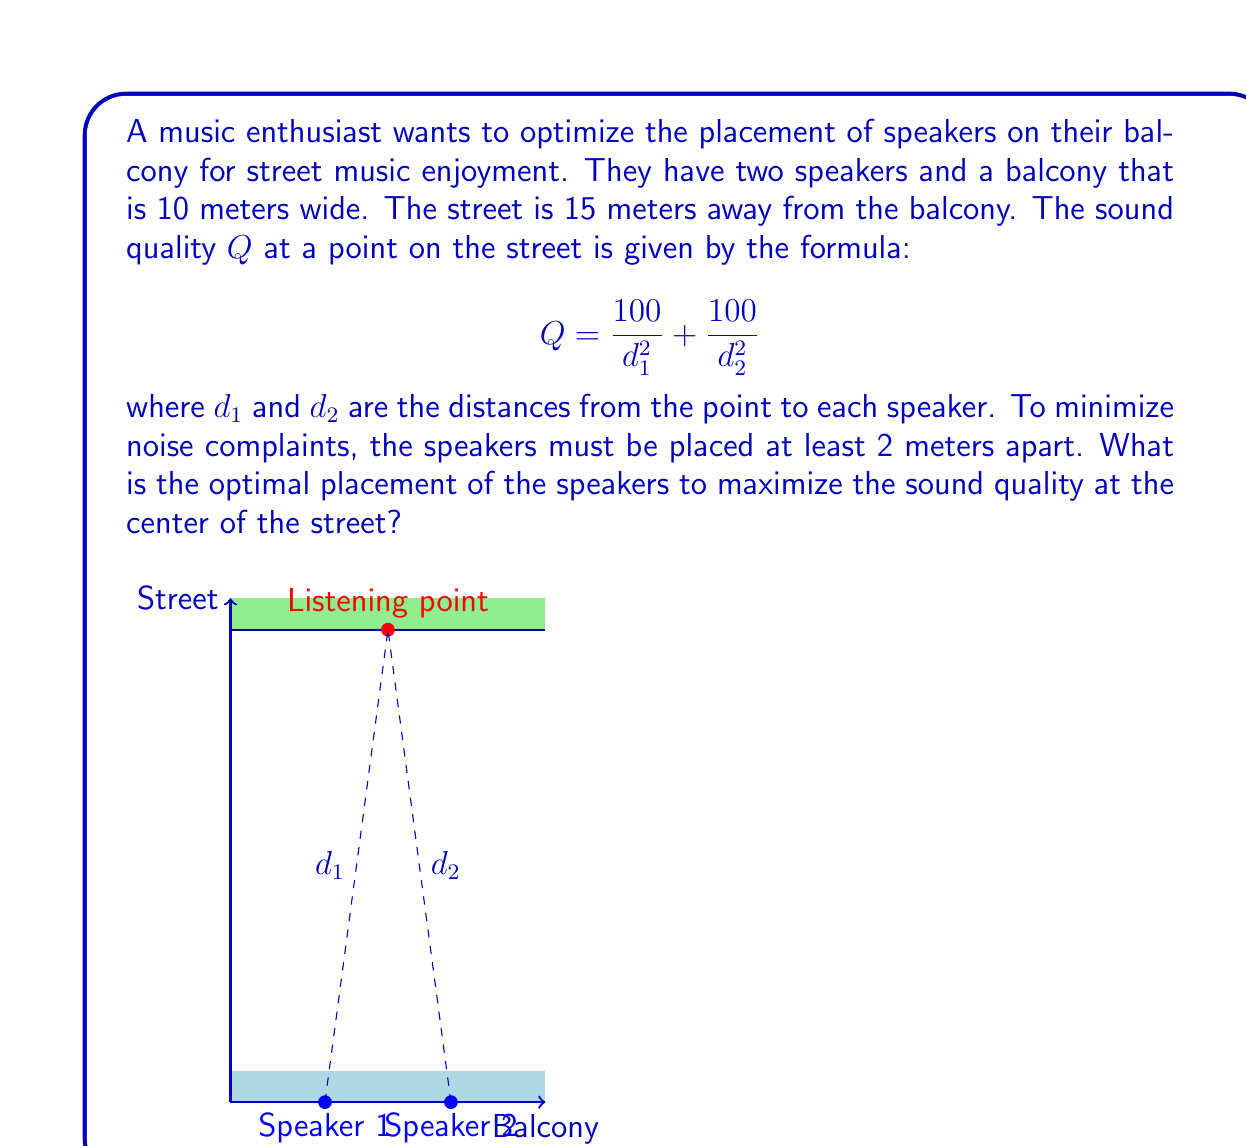Could you help me with this problem? Let's approach this step-by-step:

1) Let the positions of the speakers be $x$ and $10-x$ meters from the left edge of the balcony. Due to symmetry, the optimal placement will be equidistant from the center.

2) The distance $d_1$ from the first speaker to the listening point is:
   $$d_1 = \sqrt{(5-x)^2 + 15^2}$$

3) Similarly, for the second speaker:
   $$d_2 = \sqrt{(5-(10-x))^2 + 15^2} = \sqrt{(x-5)^2 + 15^2}$$

4) The sound quality function becomes:
   $$Q = \frac{100}{(5-x)^2 + 15^2} + \frac{100}{(x-5)^2 + 15^2}$$

5) To maximize Q, we need to minimize the denominator. Let's call the denominator D:
   $$D = (5-x)^2 + 15^2 + (x-5)^2 + 15^2 = 2((x-5)^2 + 15^2)$$

6) To find the minimum, we differentiate D with respect to x and set it to zero:
   $$\frac{dD}{dx} = 4(x-5) = 0$$

7) Solving this, we get $x = 5$. This means the speakers should be placed symmetrically at 5 meters from each edge.

8) However, we need to check the constraint that the speakers must be at least 2 meters apart. The distance between speakers is $10-2x$.

9) So, we need: $10-2x \geq 2$, or $x \leq 4$

10) Therefore, the optimal placement is at $x = 4$ and $10-x = 6$ meters from the left edge of the balcony.
Answer: 4 meters and 6 meters from the left edge of the balcony 